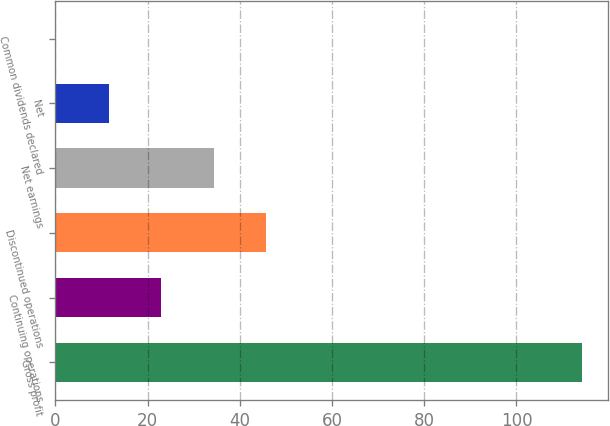<chart> <loc_0><loc_0><loc_500><loc_500><bar_chart><fcel>Gross profit<fcel>Continuing operations<fcel>Discontinued operations<fcel>Net earnings<fcel>Net<fcel>Common dividends declared<nl><fcel>114.2<fcel>22.95<fcel>45.77<fcel>34.36<fcel>11.54<fcel>0.13<nl></chart> 